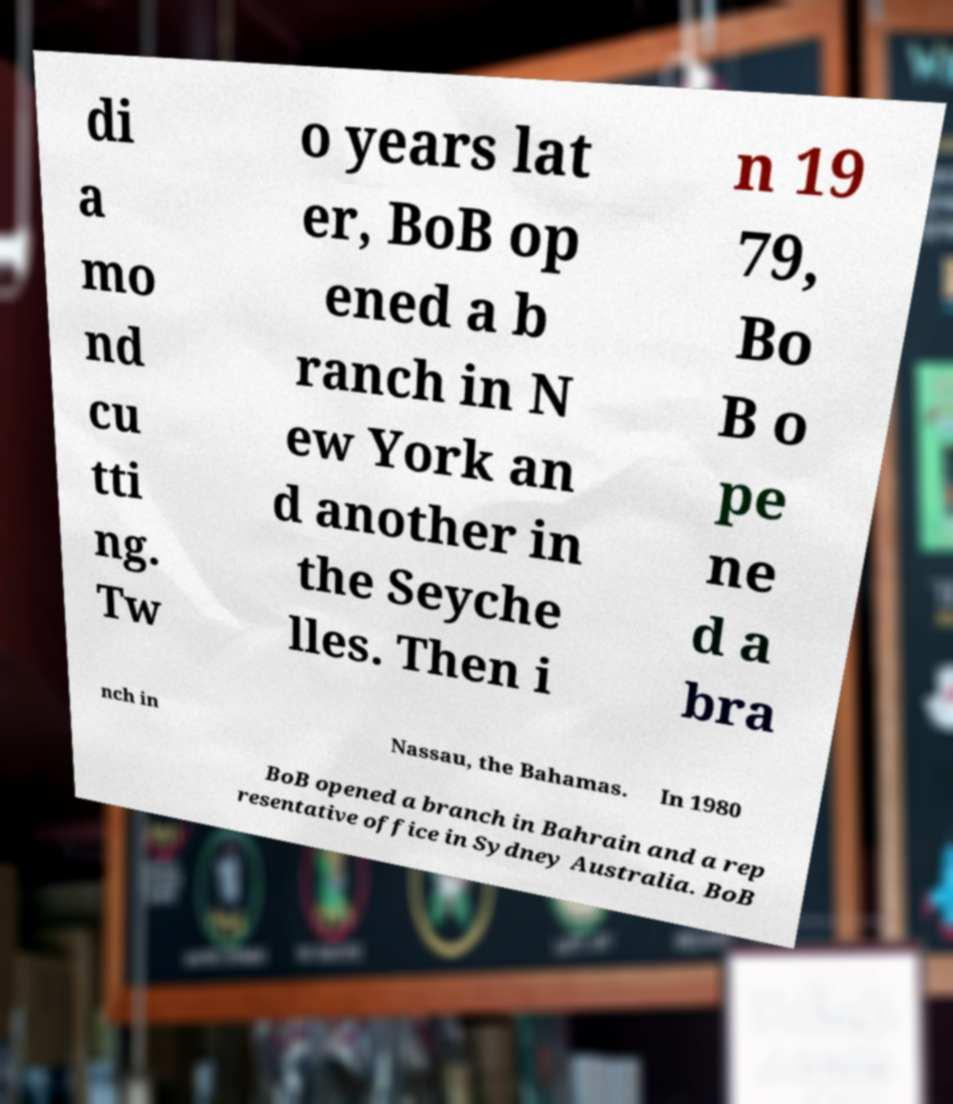There's text embedded in this image that I need extracted. Can you transcribe it verbatim? di a mo nd cu tti ng. Tw o years lat er, BoB op ened a b ranch in N ew York an d another in the Seyche lles. Then i n 19 79, Bo B o pe ne d a bra nch in Nassau, the Bahamas. In 1980 BoB opened a branch in Bahrain and a rep resentative office in Sydney Australia. BoB 